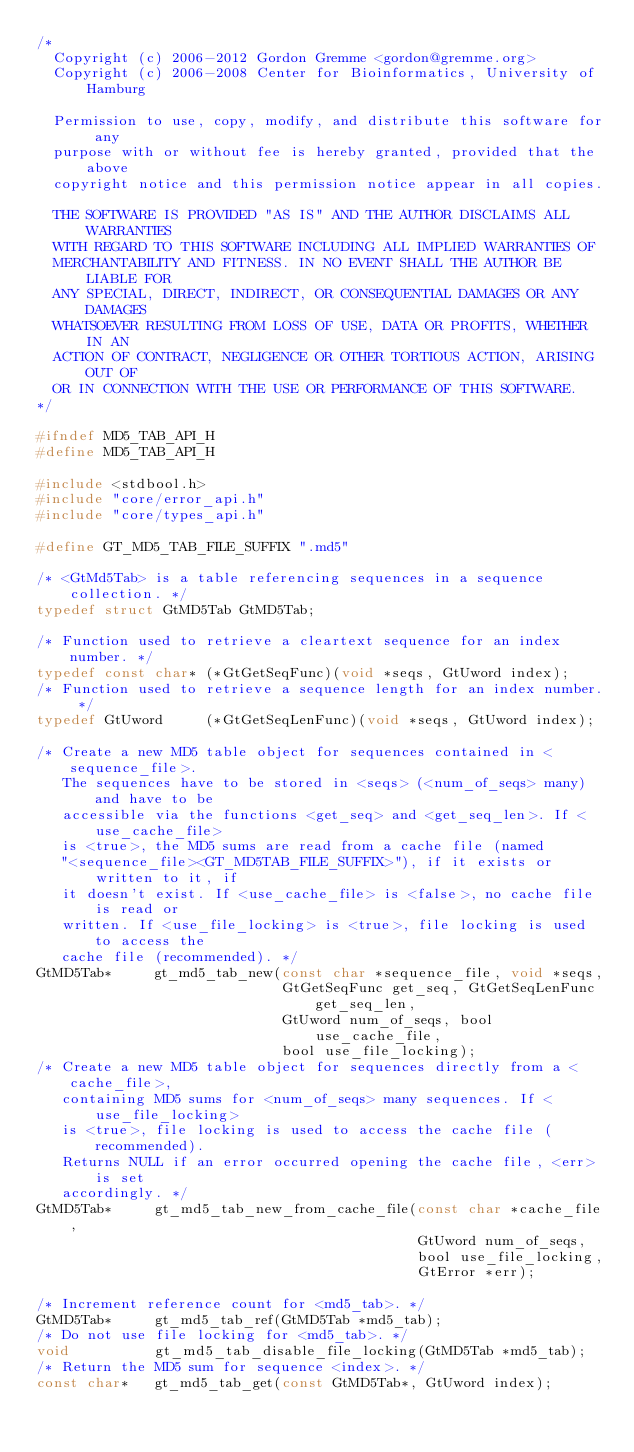<code> <loc_0><loc_0><loc_500><loc_500><_C_>/*
  Copyright (c) 2006-2012 Gordon Gremme <gordon@gremme.org>
  Copyright (c) 2006-2008 Center for Bioinformatics, University of Hamburg

  Permission to use, copy, modify, and distribute this software for any
  purpose with or without fee is hereby granted, provided that the above
  copyright notice and this permission notice appear in all copies.

  THE SOFTWARE IS PROVIDED "AS IS" AND THE AUTHOR DISCLAIMS ALL WARRANTIES
  WITH REGARD TO THIS SOFTWARE INCLUDING ALL IMPLIED WARRANTIES OF
  MERCHANTABILITY AND FITNESS. IN NO EVENT SHALL THE AUTHOR BE LIABLE FOR
  ANY SPECIAL, DIRECT, INDIRECT, OR CONSEQUENTIAL DAMAGES OR ANY DAMAGES
  WHATSOEVER RESULTING FROM LOSS OF USE, DATA OR PROFITS, WHETHER IN AN
  ACTION OF CONTRACT, NEGLIGENCE OR OTHER TORTIOUS ACTION, ARISING OUT OF
  OR IN CONNECTION WITH THE USE OR PERFORMANCE OF THIS SOFTWARE.
*/

#ifndef MD5_TAB_API_H
#define MD5_TAB_API_H

#include <stdbool.h>
#include "core/error_api.h"
#include "core/types_api.h"

#define GT_MD5_TAB_FILE_SUFFIX ".md5"

/* <GtMd5Tab> is a table referencing sequences in a sequence collection. */
typedef struct GtMD5Tab GtMD5Tab;

/* Function used to retrieve a cleartext sequence for an index number. */
typedef const char* (*GtGetSeqFunc)(void *seqs, GtUword index);
/* Function used to retrieve a sequence length for an index number. */
typedef GtUword     (*GtGetSeqLenFunc)(void *seqs, GtUword index);

/* Create a new MD5 table object for sequences contained in <sequence_file>.
   The sequences have to be stored in <seqs> (<num_of_seqs> many) and have to be
   accessible via the functions <get_seq> and <get_seq_len>. If <use_cache_file>
   is <true>, the MD5 sums are read from a cache file (named
   "<sequence_file><GT_MD5TAB_FILE_SUFFIX>"), if it exists or written to it, if
   it doesn't exist. If <use_cache_file> is <false>, no cache file is read or
   written. If <use_file_locking> is <true>, file locking is used to access the
   cache file (recommended). */
GtMD5Tab*     gt_md5_tab_new(const char *sequence_file, void *seqs,
                             GtGetSeqFunc get_seq, GtGetSeqLenFunc get_seq_len,
                             GtUword num_of_seqs, bool use_cache_file,
                             bool use_file_locking);
/* Create a new MD5 table object for sequences directly from a <cache_file>,
   containing MD5 sums for <num_of_seqs> many sequences. If <use_file_locking>
   is <true>, file locking is used to access the cache file (recommended).
   Returns NULL if an error occurred opening the cache file, <err> is set
   accordingly. */
GtMD5Tab*     gt_md5_tab_new_from_cache_file(const char *cache_file,
                                             GtUword num_of_seqs,
                                             bool use_file_locking,
                                             GtError *err);

/* Increment reference count for <md5_tab>. */
GtMD5Tab*     gt_md5_tab_ref(GtMD5Tab *md5_tab);
/* Do not use file locking for <md5_tab>. */
void          gt_md5_tab_disable_file_locking(GtMD5Tab *md5_tab);
/* Return the MD5 sum for sequence <index>. */
const char*   gt_md5_tab_get(const GtMD5Tab*, GtUword index);</code> 